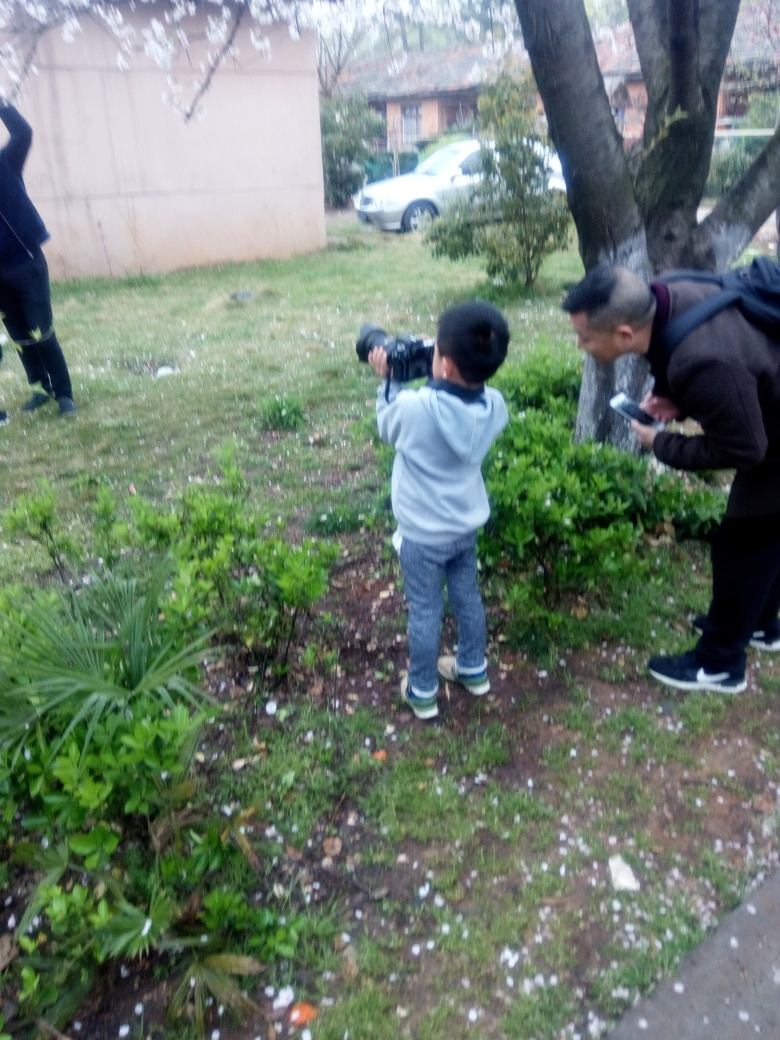Can you describe the setting and ambiance of the photo? The photo captures an outdoor scene in a garden or park area with various plants and fallen petals on the ground, suggesting a tranquil and natural setting. The overcast sky implies a cloudy day, which contributes to the serene atmosphere. 